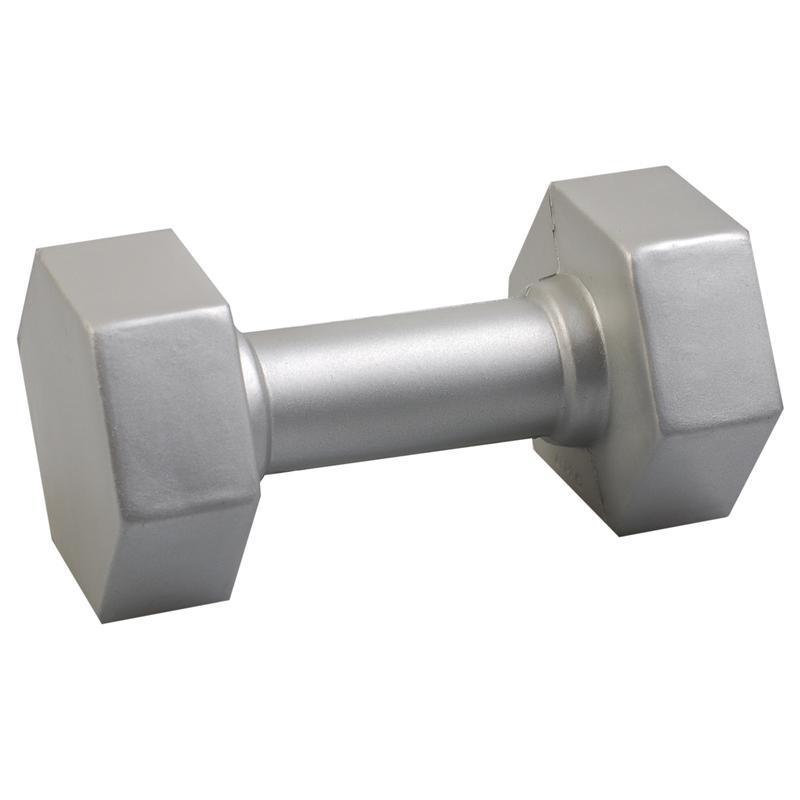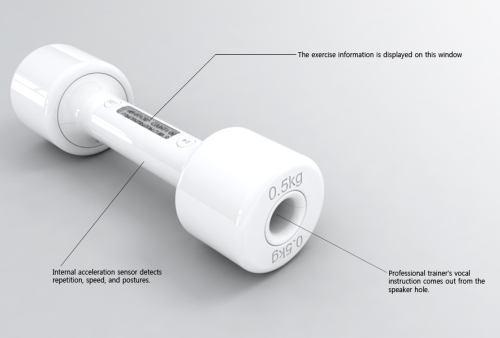The first image is the image on the left, the second image is the image on the right. Given the left and right images, does the statement "AN image shows exactly one black dumbbell." hold true? Answer yes or no. No. The first image is the image on the left, the second image is the image on the right. Analyze the images presented: Is the assertion "There is one black free weight" valid? Answer yes or no. No. 